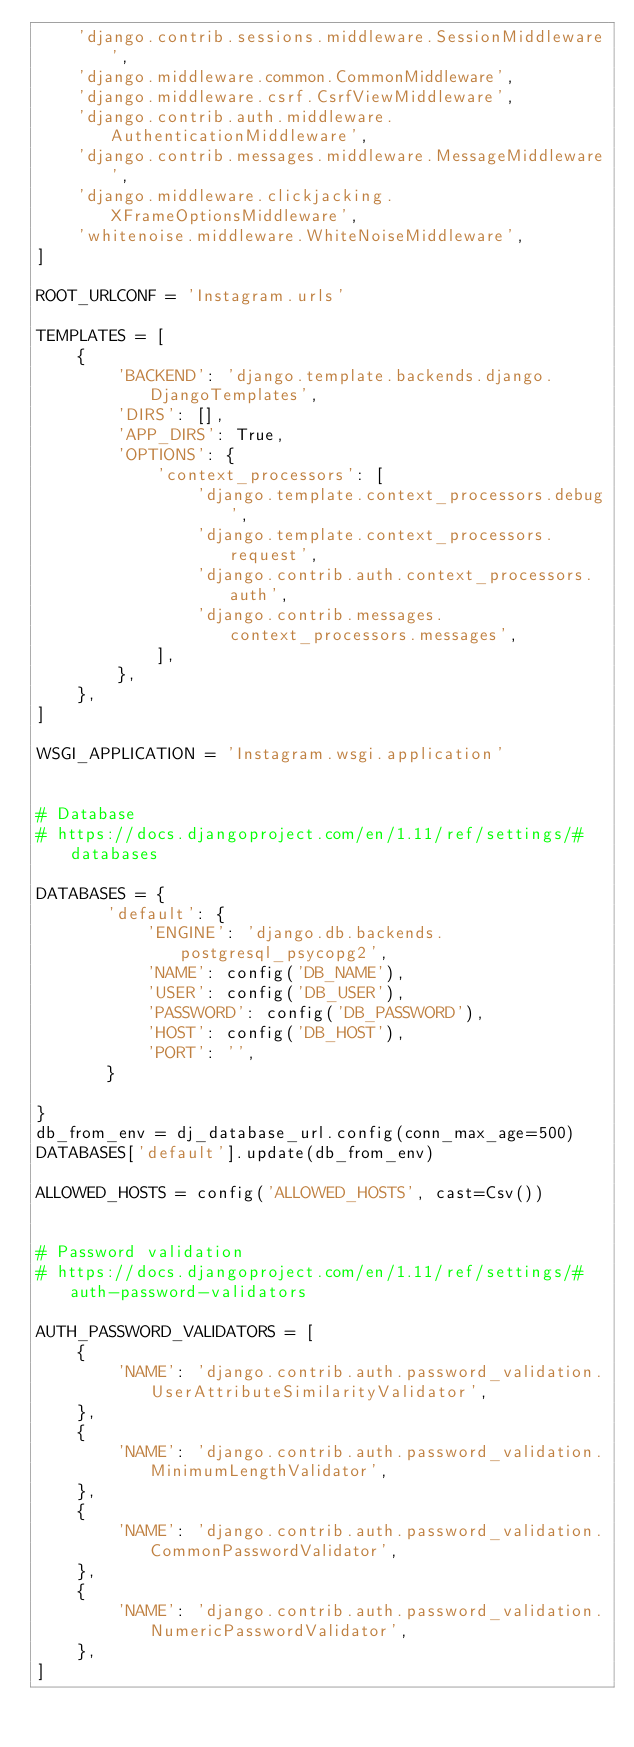Convert code to text. <code><loc_0><loc_0><loc_500><loc_500><_Python_>    'django.contrib.sessions.middleware.SessionMiddleware',
    'django.middleware.common.CommonMiddleware',
    'django.middleware.csrf.CsrfViewMiddleware',
    'django.contrib.auth.middleware.AuthenticationMiddleware',
    'django.contrib.messages.middleware.MessageMiddleware',
    'django.middleware.clickjacking.XFrameOptionsMiddleware',
    'whitenoise.middleware.WhiteNoiseMiddleware',
]

ROOT_URLCONF = 'Instagram.urls'

TEMPLATES = [
    {
        'BACKEND': 'django.template.backends.django.DjangoTemplates',
        'DIRS': [],
        'APP_DIRS': True,
        'OPTIONS': {
            'context_processors': [
                'django.template.context_processors.debug',
                'django.template.context_processors.request',
                'django.contrib.auth.context_processors.auth',
                'django.contrib.messages.context_processors.messages',
            ],
        },
    },
]

WSGI_APPLICATION = 'Instagram.wsgi.application'


# Database
# https://docs.djangoproject.com/en/1.11/ref/settings/#databases

DATABASES = {
       'default': {
           'ENGINE': 'django.db.backends.postgresql_psycopg2',
           'NAME': config('DB_NAME'),
           'USER': config('DB_USER'),
           'PASSWORD': config('DB_PASSWORD'),
           'HOST': config('DB_HOST'),
           'PORT': '',
       }

}
db_from_env = dj_database_url.config(conn_max_age=500)
DATABASES['default'].update(db_from_env)

ALLOWED_HOSTS = config('ALLOWED_HOSTS', cast=Csv())


# Password validation
# https://docs.djangoproject.com/en/1.11/ref/settings/#auth-password-validators

AUTH_PASSWORD_VALIDATORS = [
    {
        'NAME': 'django.contrib.auth.password_validation.UserAttributeSimilarityValidator',
    },
    {
        'NAME': 'django.contrib.auth.password_validation.MinimumLengthValidator',
    },
    {
        'NAME': 'django.contrib.auth.password_validation.CommonPasswordValidator',
    },
    {
        'NAME': 'django.contrib.auth.password_validation.NumericPasswordValidator',
    },
]

</code> 